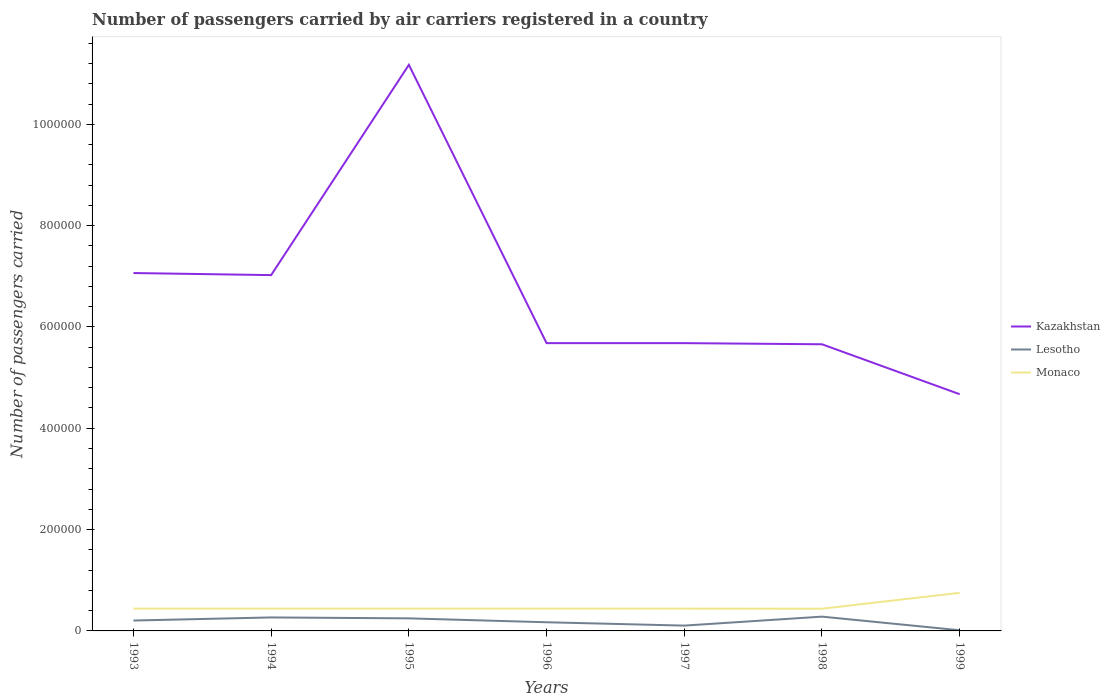How many different coloured lines are there?
Ensure brevity in your answer.  3. Across all years, what is the maximum number of passengers carried by air carriers in Monaco?
Offer a terse response. 4.38e+04. What is the total number of passengers carried by air carriers in Lesotho in the graph?
Your answer should be compact. 1.58e+04. What is the difference between the highest and the second highest number of passengers carried by air carriers in Kazakhstan?
Provide a short and direct response. 6.50e+05. Is the number of passengers carried by air carriers in Kazakhstan strictly greater than the number of passengers carried by air carriers in Lesotho over the years?
Ensure brevity in your answer.  No. How many lines are there?
Give a very brief answer. 3. How many years are there in the graph?
Your answer should be very brief. 7. Are the values on the major ticks of Y-axis written in scientific E-notation?
Provide a short and direct response. No. Where does the legend appear in the graph?
Provide a short and direct response. Center right. How many legend labels are there?
Offer a terse response. 3. What is the title of the graph?
Provide a succinct answer. Number of passengers carried by air carriers registered in a country. What is the label or title of the Y-axis?
Your response must be concise. Number of passengers carried. What is the Number of passengers carried of Kazakhstan in 1993?
Offer a very short reply. 7.06e+05. What is the Number of passengers carried of Lesotho in 1993?
Make the answer very short. 2.05e+04. What is the Number of passengers carried in Monaco in 1993?
Keep it short and to the point. 4.40e+04. What is the Number of passengers carried in Kazakhstan in 1994?
Your answer should be very brief. 7.02e+05. What is the Number of passengers carried in Lesotho in 1994?
Ensure brevity in your answer.  2.66e+04. What is the Number of passengers carried of Monaco in 1994?
Offer a very short reply. 4.40e+04. What is the Number of passengers carried of Kazakhstan in 1995?
Offer a terse response. 1.12e+06. What is the Number of passengers carried in Lesotho in 1995?
Keep it short and to the point. 2.48e+04. What is the Number of passengers carried in Monaco in 1995?
Ensure brevity in your answer.  4.40e+04. What is the Number of passengers carried of Kazakhstan in 1996?
Keep it short and to the point. 5.68e+05. What is the Number of passengers carried in Lesotho in 1996?
Offer a very short reply. 1.71e+04. What is the Number of passengers carried of Monaco in 1996?
Keep it short and to the point. 4.40e+04. What is the Number of passengers carried of Kazakhstan in 1997?
Make the answer very short. 5.68e+05. What is the Number of passengers carried of Lesotho in 1997?
Keep it short and to the point. 1.05e+04. What is the Number of passengers carried of Monaco in 1997?
Make the answer very short. 4.40e+04. What is the Number of passengers carried in Kazakhstan in 1998?
Offer a terse response. 5.66e+05. What is the Number of passengers carried of Lesotho in 1998?
Your answer should be compact. 2.82e+04. What is the Number of passengers carried in Monaco in 1998?
Provide a succinct answer. 4.38e+04. What is the Number of passengers carried of Kazakhstan in 1999?
Your answer should be very brief. 4.67e+05. What is the Number of passengers carried in Lesotho in 1999?
Your answer should be compact. 1300. What is the Number of passengers carried of Monaco in 1999?
Offer a terse response. 7.52e+04. Across all years, what is the maximum Number of passengers carried in Kazakhstan?
Give a very brief answer. 1.12e+06. Across all years, what is the maximum Number of passengers carried of Lesotho?
Your answer should be very brief. 2.82e+04. Across all years, what is the maximum Number of passengers carried of Monaco?
Your response must be concise. 7.52e+04. Across all years, what is the minimum Number of passengers carried of Kazakhstan?
Ensure brevity in your answer.  4.67e+05. Across all years, what is the minimum Number of passengers carried of Lesotho?
Your answer should be very brief. 1300. Across all years, what is the minimum Number of passengers carried in Monaco?
Your response must be concise. 4.38e+04. What is the total Number of passengers carried in Kazakhstan in the graph?
Keep it short and to the point. 4.70e+06. What is the total Number of passengers carried of Lesotho in the graph?
Provide a succinct answer. 1.29e+05. What is the total Number of passengers carried in Monaco in the graph?
Make the answer very short. 3.39e+05. What is the difference between the Number of passengers carried in Kazakhstan in 1993 and that in 1994?
Provide a short and direct response. 4100. What is the difference between the Number of passengers carried of Lesotho in 1993 and that in 1994?
Provide a succinct answer. -6100. What is the difference between the Number of passengers carried of Kazakhstan in 1993 and that in 1995?
Your answer should be very brief. -4.11e+05. What is the difference between the Number of passengers carried of Lesotho in 1993 and that in 1995?
Offer a very short reply. -4300. What is the difference between the Number of passengers carried in Monaco in 1993 and that in 1995?
Give a very brief answer. 0. What is the difference between the Number of passengers carried of Kazakhstan in 1993 and that in 1996?
Keep it short and to the point. 1.38e+05. What is the difference between the Number of passengers carried of Lesotho in 1993 and that in 1996?
Your answer should be compact. 3400. What is the difference between the Number of passengers carried in Monaco in 1993 and that in 1996?
Give a very brief answer. 0. What is the difference between the Number of passengers carried in Kazakhstan in 1993 and that in 1997?
Provide a short and direct response. 1.38e+05. What is the difference between the Number of passengers carried in Lesotho in 1993 and that in 1997?
Ensure brevity in your answer.  10000. What is the difference between the Number of passengers carried of Monaco in 1993 and that in 1997?
Give a very brief answer. 0. What is the difference between the Number of passengers carried of Kazakhstan in 1993 and that in 1998?
Your answer should be very brief. 1.41e+05. What is the difference between the Number of passengers carried in Lesotho in 1993 and that in 1998?
Keep it short and to the point. -7700. What is the difference between the Number of passengers carried of Kazakhstan in 1993 and that in 1999?
Offer a very short reply. 2.39e+05. What is the difference between the Number of passengers carried of Lesotho in 1993 and that in 1999?
Offer a terse response. 1.92e+04. What is the difference between the Number of passengers carried of Monaco in 1993 and that in 1999?
Provide a succinct answer. -3.12e+04. What is the difference between the Number of passengers carried in Kazakhstan in 1994 and that in 1995?
Keep it short and to the point. -4.15e+05. What is the difference between the Number of passengers carried of Lesotho in 1994 and that in 1995?
Your answer should be compact. 1800. What is the difference between the Number of passengers carried in Kazakhstan in 1994 and that in 1996?
Give a very brief answer. 1.34e+05. What is the difference between the Number of passengers carried in Lesotho in 1994 and that in 1996?
Provide a short and direct response. 9500. What is the difference between the Number of passengers carried of Monaco in 1994 and that in 1996?
Make the answer very short. 0. What is the difference between the Number of passengers carried of Kazakhstan in 1994 and that in 1997?
Provide a succinct answer. 1.34e+05. What is the difference between the Number of passengers carried in Lesotho in 1994 and that in 1997?
Offer a terse response. 1.61e+04. What is the difference between the Number of passengers carried of Kazakhstan in 1994 and that in 1998?
Offer a terse response. 1.36e+05. What is the difference between the Number of passengers carried of Lesotho in 1994 and that in 1998?
Provide a succinct answer. -1600. What is the difference between the Number of passengers carried of Monaco in 1994 and that in 1998?
Offer a very short reply. 200. What is the difference between the Number of passengers carried of Kazakhstan in 1994 and that in 1999?
Provide a succinct answer. 2.35e+05. What is the difference between the Number of passengers carried in Lesotho in 1994 and that in 1999?
Ensure brevity in your answer.  2.53e+04. What is the difference between the Number of passengers carried in Monaco in 1994 and that in 1999?
Your response must be concise. -3.12e+04. What is the difference between the Number of passengers carried of Kazakhstan in 1995 and that in 1996?
Keep it short and to the point. 5.49e+05. What is the difference between the Number of passengers carried of Lesotho in 1995 and that in 1996?
Your response must be concise. 7700. What is the difference between the Number of passengers carried of Monaco in 1995 and that in 1996?
Ensure brevity in your answer.  0. What is the difference between the Number of passengers carried of Kazakhstan in 1995 and that in 1997?
Give a very brief answer. 5.49e+05. What is the difference between the Number of passengers carried of Lesotho in 1995 and that in 1997?
Your response must be concise. 1.43e+04. What is the difference between the Number of passengers carried of Kazakhstan in 1995 and that in 1998?
Provide a succinct answer. 5.52e+05. What is the difference between the Number of passengers carried in Lesotho in 1995 and that in 1998?
Your response must be concise. -3400. What is the difference between the Number of passengers carried of Monaco in 1995 and that in 1998?
Ensure brevity in your answer.  200. What is the difference between the Number of passengers carried of Kazakhstan in 1995 and that in 1999?
Your response must be concise. 6.50e+05. What is the difference between the Number of passengers carried in Lesotho in 1995 and that in 1999?
Provide a short and direct response. 2.35e+04. What is the difference between the Number of passengers carried of Monaco in 1995 and that in 1999?
Keep it short and to the point. -3.12e+04. What is the difference between the Number of passengers carried in Kazakhstan in 1996 and that in 1997?
Give a very brief answer. 0. What is the difference between the Number of passengers carried in Lesotho in 1996 and that in 1997?
Your answer should be compact. 6600. What is the difference between the Number of passengers carried of Monaco in 1996 and that in 1997?
Offer a very short reply. 0. What is the difference between the Number of passengers carried in Kazakhstan in 1996 and that in 1998?
Offer a very short reply. 2200. What is the difference between the Number of passengers carried in Lesotho in 1996 and that in 1998?
Ensure brevity in your answer.  -1.11e+04. What is the difference between the Number of passengers carried of Monaco in 1996 and that in 1998?
Make the answer very short. 200. What is the difference between the Number of passengers carried in Kazakhstan in 1996 and that in 1999?
Offer a terse response. 1.01e+05. What is the difference between the Number of passengers carried of Lesotho in 1996 and that in 1999?
Provide a succinct answer. 1.58e+04. What is the difference between the Number of passengers carried of Monaco in 1996 and that in 1999?
Your response must be concise. -3.12e+04. What is the difference between the Number of passengers carried of Kazakhstan in 1997 and that in 1998?
Make the answer very short. 2200. What is the difference between the Number of passengers carried of Lesotho in 1997 and that in 1998?
Ensure brevity in your answer.  -1.77e+04. What is the difference between the Number of passengers carried of Kazakhstan in 1997 and that in 1999?
Provide a succinct answer. 1.01e+05. What is the difference between the Number of passengers carried of Lesotho in 1997 and that in 1999?
Provide a short and direct response. 9200. What is the difference between the Number of passengers carried in Monaco in 1997 and that in 1999?
Make the answer very short. -3.12e+04. What is the difference between the Number of passengers carried of Kazakhstan in 1998 and that in 1999?
Your response must be concise. 9.86e+04. What is the difference between the Number of passengers carried in Lesotho in 1998 and that in 1999?
Your answer should be compact. 2.69e+04. What is the difference between the Number of passengers carried of Monaco in 1998 and that in 1999?
Offer a terse response. -3.14e+04. What is the difference between the Number of passengers carried in Kazakhstan in 1993 and the Number of passengers carried in Lesotho in 1994?
Keep it short and to the point. 6.80e+05. What is the difference between the Number of passengers carried in Kazakhstan in 1993 and the Number of passengers carried in Monaco in 1994?
Your answer should be very brief. 6.62e+05. What is the difference between the Number of passengers carried of Lesotho in 1993 and the Number of passengers carried of Monaco in 1994?
Your answer should be compact. -2.35e+04. What is the difference between the Number of passengers carried in Kazakhstan in 1993 and the Number of passengers carried in Lesotho in 1995?
Offer a terse response. 6.82e+05. What is the difference between the Number of passengers carried in Kazakhstan in 1993 and the Number of passengers carried in Monaco in 1995?
Provide a short and direct response. 6.62e+05. What is the difference between the Number of passengers carried in Lesotho in 1993 and the Number of passengers carried in Monaco in 1995?
Give a very brief answer. -2.35e+04. What is the difference between the Number of passengers carried of Kazakhstan in 1993 and the Number of passengers carried of Lesotho in 1996?
Provide a succinct answer. 6.89e+05. What is the difference between the Number of passengers carried of Kazakhstan in 1993 and the Number of passengers carried of Monaco in 1996?
Make the answer very short. 6.62e+05. What is the difference between the Number of passengers carried in Lesotho in 1993 and the Number of passengers carried in Monaco in 1996?
Your answer should be very brief. -2.35e+04. What is the difference between the Number of passengers carried in Kazakhstan in 1993 and the Number of passengers carried in Lesotho in 1997?
Your answer should be compact. 6.96e+05. What is the difference between the Number of passengers carried in Kazakhstan in 1993 and the Number of passengers carried in Monaco in 1997?
Make the answer very short. 6.62e+05. What is the difference between the Number of passengers carried in Lesotho in 1993 and the Number of passengers carried in Monaco in 1997?
Keep it short and to the point. -2.35e+04. What is the difference between the Number of passengers carried of Kazakhstan in 1993 and the Number of passengers carried of Lesotho in 1998?
Make the answer very short. 6.78e+05. What is the difference between the Number of passengers carried in Kazakhstan in 1993 and the Number of passengers carried in Monaco in 1998?
Ensure brevity in your answer.  6.63e+05. What is the difference between the Number of passengers carried in Lesotho in 1993 and the Number of passengers carried in Monaco in 1998?
Offer a very short reply. -2.33e+04. What is the difference between the Number of passengers carried of Kazakhstan in 1993 and the Number of passengers carried of Lesotho in 1999?
Your answer should be very brief. 7.05e+05. What is the difference between the Number of passengers carried of Kazakhstan in 1993 and the Number of passengers carried of Monaco in 1999?
Make the answer very short. 6.31e+05. What is the difference between the Number of passengers carried in Lesotho in 1993 and the Number of passengers carried in Monaco in 1999?
Provide a short and direct response. -5.47e+04. What is the difference between the Number of passengers carried of Kazakhstan in 1994 and the Number of passengers carried of Lesotho in 1995?
Your answer should be very brief. 6.78e+05. What is the difference between the Number of passengers carried in Kazakhstan in 1994 and the Number of passengers carried in Monaco in 1995?
Make the answer very short. 6.58e+05. What is the difference between the Number of passengers carried in Lesotho in 1994 and the Number of passengers carried in Monaco in 1995?
Give a very brief answer. -1.74e+04. What is the difference between the Number of passengers carried of Kazakhstan in 1994 and the Number of passengers carried of Lesotho in 1996?
Offer a very short reply. 6.85e+05. What is the difference between the Number of passengers carried of Kazakhstan in 1994 and the Number of passengers carried of Monaco in 1996?
Your response must be concise. 6.58e+05. What is the difference between the Number of passengers carried in Lesotho in 1994 and the Number of passengers carried in Monaco in 1996?
Provide a short and direct response. -1.74e+04. What is the difference between the Number of passengers carried in Kazakhstan in 1994 and the Number of passengers carried in Lesotho in 1997?
Offer a very short reply. 6.92e+05. What is the difference between the Number of passengers carried in Kazakhstan in 1994 and the Number of passengers carried in Monaco in 1997?
Provide a short and direct response. 6.58e+05. What is the difference between the Number of passengers carried of Lesotho in 1994 and the Number of passengers carried of Monaco in 1997?
Offer a terse response. -1.74e+04. What is the difference between the Number of passengers carried of Kazakhstan in 1994 and the Number of passengers carried of Lesotho in 1998?
Provide a succinct answer. 6.74e+05. What is the difference between the Number of passengers carried of Kazakhstan in 1994 and the Number of passengers carried of Monaco in 1998?
Your answer should be compact. 6.58e+05. What is the difference between the Number of passengers carried in Lesotho in 1994 and the Number of passengers carried in Monaco in 1998?
Keep it short and to the point. -1.72e+04. What is the difference between the Number of passengers carried of Kazakhstan in 1994 and the Number of passengers carried of Lesotho in 1999?
Provide a succinct answer. 7.01e+05. What is the difference between the Number of passengers carried of Kazakhstan in 1994 and the Number of passengers carried of Monaco in 1999?
Your answer should be compact. 6.27e+05. What is the difference between the Number of passengers carried of Lesotho in 1994 and the Number of passengers carried of Monaco in 1999?
Make the answer very short. -4.86e+04. What is the difference between the Number of passengers carried in Kazakhstan in 1995 and the Number of passengers carried in Lesotho in 1996?
Offer a very short reply. 1.10e+06. What is the difference between the Number of passengers carried of Kazakhstan in 1995 and the Number of passengers carried of Monaco in 1996?
Ensure brevity in your answer.  1.07e+06. What is the difference between the Number of passengers carried in Lesotho in 1995 and the Number of passengers carried in Monaco in 1996?
Keep it short and to the point. -1.92e+04. What is the difference between the Number of passengers carried in Kazakhstan in 1995 and the Number of passengers carried in Lesotho in 1997?
Give a very brief answer. 1.11e+06. What is the difference between the Number of passengers carried of Kazakhstan in 1995 and the Number of passengers carried of Monaco in 1997?
Give a very brief answer. 1.07e+06. What is the difference between the Number of passengers carried in Lesotho in 1995 and the Number of passengers carried in Monaco in 1997?
Your response must be concise. -1.92e+04. What is the difference between the Number of passengers carried of Kazakhstan in 1995 and the Number of passengers carried of Lesotho in 1998?
Provide a short and direct response. 1.09e+06. What is the difference between the Number of passengers carried in Kazakhstan in 1995 and the Number of passengers carried in Monaco in 1998?
Your answer should be compact. 1.07e+06. What is the difference between the Number of passengers carried in Lesotho in 1995 and the Number of passengers carried in Monaco in 1998?
Your answer should be compact. -1.90e+04. What is the difference between the Number of passengers carried of Kazakhstan in 1995 and the Number of passengers carried of Lesotho in 1999?
Your answer should be very brief. 1.12e+06. What is the difference between the Number of passengers carried of Kazakhstan in 1995 and the Number of passengers carried of Monaco in 1999?
Make the answer very short. 1.04e+06. What is the difference between the Number of passengers carried of Lesotho in 1995 and the Number of passengers carried of Monaco in 1999?
Ensure brevity in your answer.  -5.04e+04. What is the difference between the Number of passengers carried in Kazakhstan in 1996 and the Number of passengers carried in Lesotho in 1997?
Your answer should be very brief. 5.58e+05. What is the difference between the Number of passengers carried of Kazakhstan in 1996 and the Number of passengers carried of Monaco in 1997?
Offer a very short reply. 5.24e+05. What is the difference between the Number of passengers carried of Lesotho in 1996 and the Number of passengers carried of Monaco in 1997?
Provide a short and direct response. -2.69e+04. What is the difference between the Number of passengers carried of Kazakhstan in 1996 and the Number of passengers carried of Lesotho in 1998?
Ensure brevity in your answer.  5.40e+05. What is the difference between the Number of passengers carried of Kazakhstan in 1996 and the Number of passengers carried of Monaco in 1998?
Your answer should be compact. 5.24e+05. What is the difference between the Number of passengers carried in Lesotho in 1996 and the Number of passengers carried in Monaco in 1998?
Your response must be concise. -2.67e+04. What is the difference between the Number of passengers carried of Kazakhstan in 1996 and the Number of passengers carried of Lesotho in 1999?
Provide a short and direct response. 5.67e+05. What is the difference between the Number of passengers carried of Kazakhstan in 1996 and the Number of passengers carried of Monaco in 1999?
Give a very brief answer. 4.93e+05. What is the difference between the Number of passengers carried in Lesotho in 1996 and the Number of passengers carried in Monaco in 1999?
Give a very brief answer. -5.81e+04. What is the difference between the Number of passengers carried in Kazakhstan in 1997 and the Number of passengers carried in Lesotho in 1998?
Your answer should be compact. 5.40e+05. What is the difference between the Number of passengers carried in Kazakhstan in 1997 and the Number of passengers carried in Monaco in 1998?
Your answer should be compact. 5.24e+05. What is the difference between the Number of passengers carried in Lesotho in 1997 and the Number of passengers carried in Monaco in 1998?
Ensure brevity in your answer.  -3.33e+04. What is the difference between the Number of passengers carried in Kazakhstan in 1997 and the Number of passengers carried in Lesotho in 1999?
Offer a very short reply. 5.67e+05. What is the difference between the Number of passengers carried of Kazakhstan in 1997 and the Number of passengers carried of Monaco in 1999?
Ensure brevity in your answer.  4.93e+05. What is the difference between the Number of passengers carried of Lesotho in 1997 and the Number of passengers carried of Monaco in 1999?
Keep it short and to the point. -6.47e+04. What is the difference between the Number of passengers carried in Kazakhstan in 1998 and the Number of passengers carried in Lesotho in 1999?
Offer a terse response. 5.64e+05. What is the difference between the Number of passengers carried of Kazakhstan in 1998 and the Number of passengers carried of Monaco in 1999?
Your answer should be compact. 4.91e+05. What is the difference between the Number of passengers carried of Lesotho in 1998 and the Number of passengers carried of Monaco in 1999?
Your response must be concise. -4.70e+04. What is the average Number of passengers carried in Kazakhstan per year?
Your response must be concise. 6.71e+05. What is the average Number of passengers carried of Lesotho per year?
Your answer should be very brief. 1.84e+04. What is the average Number of passengers carried of Monaco per year?
Offer a very short reply. 4.84e+04. In the year 1993, what is the difference between the Number of passengers carried of Kazakhstan and Number of passengers carried of Lesotho?
Keep it short and to the point. 6.86e+05. In the year 1993, what is the difference between the Number of passengers carried in Kazakhstan and Number of passengers carried in Monaco?
Make the answer very short. 6.62e+05. In the year 1993, what is the difference between the Number of passengers carried in Lesotho and Number of passengers carried in Monaco?
Your answer should be very brief. -2.35e+04. In the year 1994, what is the difference between the Number of passengers carried of Kazakhstan and Number of passengers carried of Lesotho?
Keep it short and to the point. 6.76e+05. In the year 1994, what is the difference between the Number of passengers carried in Kazakhstan and Number of passengers carried in Monaco?
Offer a very short reply. 6.58e+05. In the year 1994, what is the difference between the Number of passengers carried of Lesotho and Number of passengers carried of Monaco?
Keep it short and to the point. -1.74e+04. In the year 1995, what is the difference between the Number of passengers carried of Kazakhstan and Number of passengers carried of Lesotho?
Ensure brevity in your answer.  1.09e+06. In the year 1995, what is the difference between the Number of passengers carried of Kazakhstan and Number of passengers carried of Monaco?
Offer a very short reply. 1.07e+06. In the year 1995, what is the difference between the Number of passengers carried of Lesotho and Number of passengers carried of Monaco?
Your answer should be compact. -1.92e+04. In the year 1996, what is the difference between the Number of passengers carried of Kazakhstan and Number of passengers carried of Lesotho?
Your response must be concise. 5.51e+05. In the year 1996, what is the difference between the Number of passengers carried in Kazakhstan and Number of passengers carried in Monaco?
Offer a very short reply. 5.24e+05. In the year 1996, what is the difference between the Number of passengers carried of Lesotho and Number of passengers carried of Monaco?
Provide a succinct answer. -2.69e+04. In the year 1997, what is the difference between the Number of passengers carried of Kazakhstan and Number of passengers carried of Lesotho?
Your answer should be compact. 5.58e+05. In the year 1997, what is the difference between the Number of passengers carried of Kazakhstan and Number of passengers carried of Monaco?
Your answer should be compact. 5.24e+05. In the year 1997, what is the difference between the Number of passengers carried of Lesotho and Number of passengers carried of Monaco?
Offer a very short reply. -3.35e+04. In the year 1998, what is the difference between the Number of passengers carried of Kazakhstan and Number of passengers carried of Lesotho?
Keep it short and to the point. 5.38e+05. In the year 1998, what is the difference between the Number of passengers carried in Kazakhstan and Number of passengers carried in Monaco?
Your response must be concise. 5.22e+05. In the year 1998, what is the difference between the Number of passengers carried in Lesotho and Number of passengers carried in Monaco?
Your answer should be compact. -1.56e+04. In the year 1999, what is the difference between the Number of passengers carried of Kazakhstan and Number of passengers carried of Lesotho?
Keep it short and to the point. 4.66e+05. In the year 1999, what is the difference between the Number of passengers carried in Kazakhstan and Number of passengers carried in Monaco?
Your answer should be compact. 3.92e+05. In the year 1999, what is the difference between the Number of passengers carried in Lesotho and Number of passengers carried in Monaco?
Give a very brief answer. -7.39e+04. What is the ratio of the Number of passengers carried in Lesotho in 1993 to that in 1994?
Provide a succinct answer. 0.77. What is the ratio of the Number of passengers carried in Kazakhstan in 1993 to that in 1995?
Offer a terse response. 0.63. What is the ratio of the Number of passengers carried in Lesotho in 1993 to that in 1995?
Offer a very short reply. 0.83. What is the ratio of the Number of passengers carried in Monaco in 1993 to that in 1995?
Your response must be concise. 1. What is the ratio of the Number of passengers carried in Kazakhstan in 1993 to that in 1996?
Provide a short and direct response. 1.24. What is the ratio of the Number of passengers carried of Lesotho in 1993 to that in 1996?
Provide a short and direct response. 1.2. What is the ratio of the Number of passengers carried in Monaco in 1993 to that in 1996?
Your answer should be very brief. 1. What is the ratio of the Number of passengers carried of Kazakhstan in 1993 to that in 1997?
Provide a succinct answer. 1.24. What is the ratio of the Number of passengers carried of Lesotho in 1993 to that in 1997?
Ensure brevity in your answer.  1.95. What is the ratio of the Number of passengers carried in Kazakhstan in 1993 to that in 1998?
Your answer should be very brief. 1.25. What is the ratio of the Number of passengers carried in Lesotho in 1993 to that in 1998?
Make the answer very short. 0.73. What is the ratio of the Number of passengers carried of Kazakhstan in 1993 to that in 1999?
Keep it short and to the point. 1.51. What is the ratio of the Number of passengers carried of Lesotho in 1993 to that in 1999?
Provide a succinct answer. 15.77. What is the ratio of the Number of passengers carried in Monaco in 1993 to that in 1999?
Your response must be concise. 0.59. What is the ratio of the Number of passengers carried of Kazakhstan in 1994 to that in 1995?
Your answer should be very brief. 0.63. What is the ratio of the Number of passengers carried of Lesotho in 1994 to that in 1995?
Offer a terse response. 1.07. What is the ratio of the Number of passengers carried of Monaco in 1994 to that in 1995?
Give a very brief answer. 1. What is the ratio of the Number of passengers carried in Kazakhstan in 1994 to that in 1996?
Keep it short and to the point. 1.24. What is the ratio of the Number of passengers carried in Lesotho in 1994 to that in 1996?
Your response must be concise. 1.56. What is the ratio of the Number of passengers carried of Kazakhstan in 1994 to that in 1997?
Give a very brief answer. 1.24. What is the ratio of the Number of passengers carried in Lesotho in 1994 to that in 1997?
Provide a short and direct response. 2.53. What is the ratio of the Number of passengers carried in Kazakhstan in 1994 to that in 1998?
Offer a terse response. 1.24. What is the ratio of the Number of passengers carried of Lesotho in 1994 to that in 1998?
Provide a succinct answer. 0.94. What is the ratio of the Number of passengers carried of Kazakhstan in 1994 to that in 1999?
Your answer should be very brief. 1.5. What is the ratio of the Number of passengers carried of Lesotho in 1994 to that in 1999?
Provide a short and direct response. 20.46. What is the ratio of the Number of passengers carried of Monaco in 1994 to that in 1999?
Offer a very short reply. 0.59. What is the ratio of the Number of passengers carried of Kazakhstan in 1995 to that in 1996?
Keep it short and to the point. 1.97. What is the ratio of the Number of passengers carried of Lesotho in 1995 to that in 1996?
Your response must be concise. 1.45. What is the ratio of the Number of passengers carried of Kazakhstan in 1995 to that in 1997?
Your answer should be compact. 1.97. What is the ratio of the Number of passengers carried of Lesotho in 1995 to that in 1997?
Give a very brief answer. 2.36. What is the ratio of the Number of passengers carried in Kazakhstan in 1995 to that in 1998?
Offer a terse response. 1.97. What is the ratio of the Number of passengers carried in Lesotho in 1995 to that in 1998?
Provide a succinct answer. 0.88. What is the ratio of the Number of passengers carried in Kazakhstan in 1995 to that in 1999?
Keep it short and to the point. 2.39. What is the ratio of the Number of passengers carried in Lesotho in 1995 to that in 1999?
Offer a terse response. 19.08. What is the ratio of the Number of passengers carried of Monaco in 1995 to that in 1999?
Offer a terse response. 0.59. What is the ratio of the Number of passengers carried in Lesotho in 1996 to that in 1997?
Offer a terse response. 1.63. What is the ratio of the Number of passengers carried in Lesotho in 1996 to that in 1998?
Make the answer very short. 0.61. What is the ratio of the Number of passengers carried of Kazakhstan in 1996 to that in 1999?
Provide a short and direct response. 1.22. What is the ratio of the Number of passengers carried of Lesotho in 1996 to that in 1999?
Your response must be concise. 13.15. What is the ratio of the Number of passengers carried of Monaco in 1996 to that in 1999?
Keep it short and to the point. 0.59. What is the ratio of the Number of passengers carried in Lesotho in 1997 to that in 1998?
Provide a short and direct response. 0.37. What is the ratio of the Number of passengers carried in Monaco in 1997 to that in 1998?
Your response must be concise. 1. What is the ratio of the Number of passengers carried of Kazakhstan in 1997 to that in 1999?
Provide a succinct answer. 1.22. What is the ratio of the Number of passengers carried of Lesotho in 1997 to that in 1999?
Provide a succinct answer. 8.08. What is the ratio of the Number of passengers carried in Monaco in 1997 to that in 1999?
Your answer should be very brief. 0.59. What is the ratio of the Number of passengers carried in Kazakhstan in 1998 to that in 1999?
Make the answer very short. 1.21. What is the ratio of the Number of passengers carried in Lesotho in 1998 to that in 1999?
Offer a very short reply. 21.69. What is the ratio of the Number of passengers carried in Monaco in 1998 to that in 1999?
Your response must be concise. 0.58. What is the difference between the highest and the second highest Number of passengers carried in Kazakhstan?
Your answer should be compact. 4.11e+05. What is the difference between the highest and the second highest Number of passengers carried of Lesotho?
Give a very brief answer. 1600. What is the difference between the highest and the second highest Number of passengers carried in Monaco?
Offer a very short reply. 3.12e+04. What is the difference between the highest and the lowest Number of passengers carried in Kazakhstan?
Offer a terse response. 6.50e+05. What is the difference between the highest and the lowest Number of passengers carried of Lesotho?
Keep it short and to the point. 2.69e+04. What is the difference between the highest and the lowest Number of passengers carried in Monaco?
Your response must be concise. 3.14e+04. 